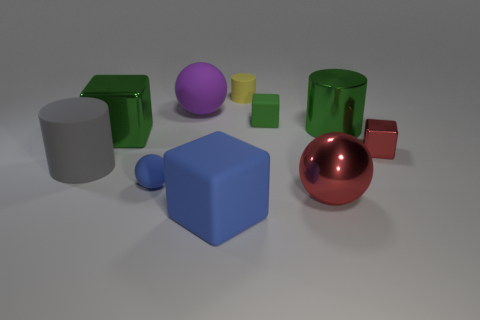What size is the red metal object that is the same shape as the big purple rubber thing?
Give a very brief answer. Large. Are there an equal number of blue rubber things to the right of the green metallic cylinder and shiny cubes that are to the right of the big blue object?
Your answer should be very brief. No. What number of other objects are there of the same material as the gray cylinder?
Keep it short and to the point. 5. Are there an equal number of rubber blocks that are on the left side of the yellow cylinder and yellow matte objects?
Offer a very short reply. Yes. There is a gray rubber cylinder; is it the same size as the sphere behind the big gray cylinder?
Give a very brief answer. Yes. The green shiny thing that is right of the yellow rubber cylinder has what shape?
Offer a terse response. Cylinder. Is there anything else that has the same shape as the gray matte object?
Provide a succinct answer. Yes. Is there a gray rubber object?
Provide a short and direct response. Yes. There is a matte block in front of the large green metal cube; is it the same size as the green object that is to the left of the small yellow matte thing?
Your answer should be very brief. Yes. There is a tiny thing that is both behind the red metallic cube and in front of the big purple rubber object; what material is it made of?
Provide a succinct answer. Rubber. 